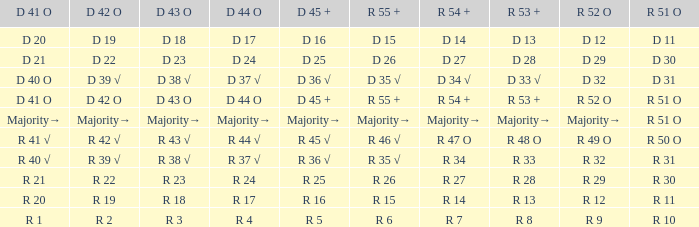What is the value of D 43 O that has a corresponding R 53 + value of r 8? R 3. 